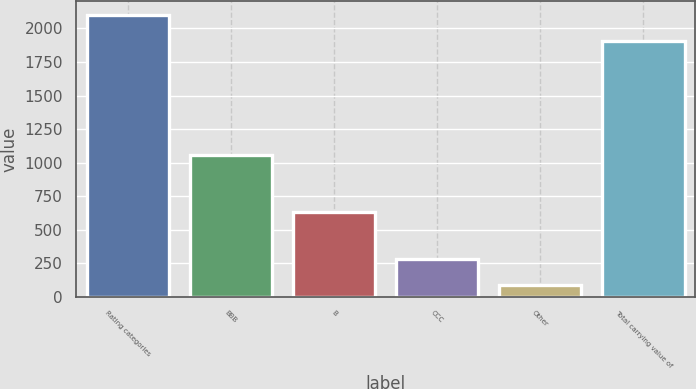Convert chart. <chart><loc_0><loc_0><loc_500><loc_500><bar_chart><fcel>Rating categories<fcel>BBB<fcel>B<fcel>CCC<fcel>Other<fcel>Total carrying value of<nl><fcel>2097.8<fcel>1055<fcel>633<fcel>278.8<fcel>86<fcel>1905<nl></chart> 